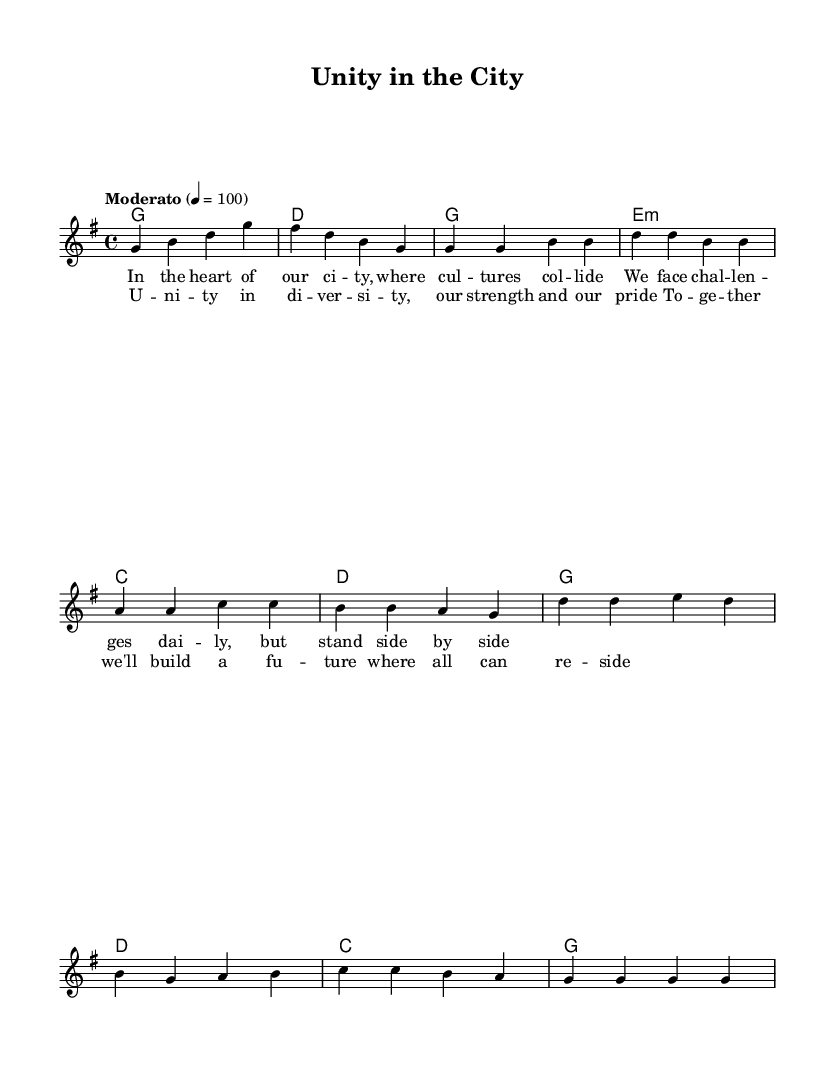What is the key signature of this music? The key signature is G major, which has one sharp (F#). You can identify the key signature at the beginning of the score, immediately to the left of the clef sign.
Answer: G major What is the time signature of this music? The time signature is 4/4, which is indicated at the beginning of the score. It means there are four beats in each measure and the quarter note gets one beat.
Answer: 4/4 What is the tempo marking for this piece? The tempo marking is "Moderato" with a metronome marking of 100. This indicates the piece should be played at a moderate speed, and the metronome marking provides a specific tempo reference.
Answer: Moderato, 100 How many measures are in the chorus section? The chorus section contains four measures. You can count the measures in the score by identifying the vertical lines that separate each measure.
Answer: 4 What is the main theme expressed in the lyrics of the verse? The main theme expressed in the verse lyrics revolves around unity and facing challenges together in a diverse urban environment. This is deduced from the content of the lyrics provided with the melody.
Answer: Unity What type of harmony is used in the verse? The harmony in the verse primarily consists of major chords such as G and D, as evidenced by the chord names written above the melody. These chords provide a strong, uplifting effect fitting for religious and interfaith contexts.
Answer: Major chords What social issue is highlighted in the music? The social issue highlighted in the music is diversity and the importance of community support in urban settings. This can be inferred from the lyrics emphasizing unity in diversity and the collaborative effort to build a positive future together.
Answer: Diversity 